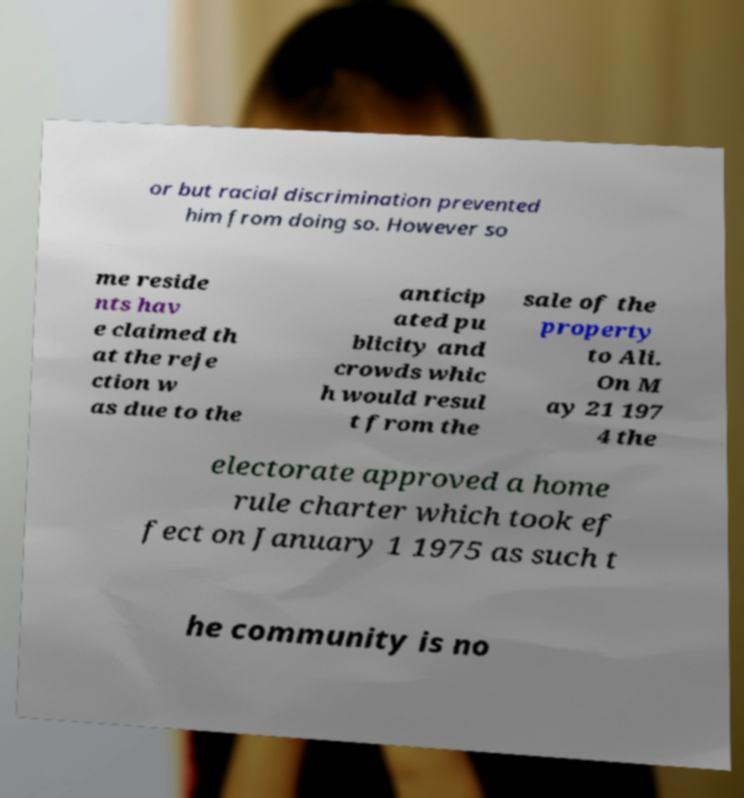There's text embedded in this image that I need extracted. Can you transcribe it verbatim? or but racial discrimination prevented him from doing so. However so me reside nts hav e claimed th at the reje ction w as due to the anticip ated pu blicity and crowds whic h would resul t from the sale of the property to Ali. On M ay 21 197 4 the electorate approved a home rule charter which took ef fect on January 1 1975 as such t he community is no 